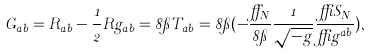Convert formula to latex. <formula><loc_0><loc_0><loc_500><loc_500>G _ { a b } = R _ { a b } - \frac { 1 } { 2 } R g _ { a b } = 8 \pi T _ { a b } = 8 \pi ( - \frac { \alpha _ { N } } { 8 \pi } \frac { 1 } { \sqrt { - g } } \frac { \delta S _ { N } } { \delta g ^ { a b } } ) ,</formula> 